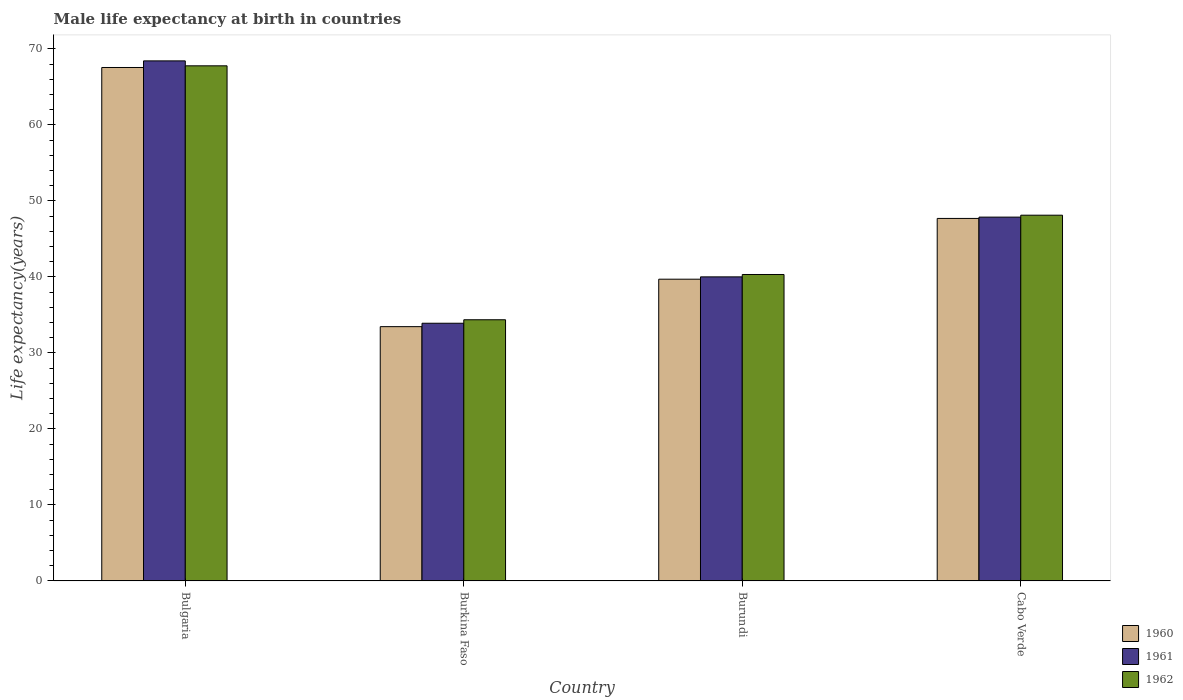How many different coloured bars are there?
Offer a terse response. 3. Are the number of bars on each tick of the X-axis equal?
Provide a succinct answer. Yes. How many bars are there on the 2nd tick from the left?
Provide a succinct answer. 3. What is the label of the 2nd group of bars from the left?
Offer a very short reply. Burkina Faso. In how many cases, is the number of bars for a given country not equal to the number of legend labels?
Your answer should be compact. 0. What is the male life expectancy at birth in 1960 in Bulgaria?
Your answer should be very brief. 67.55. Across all countries, what is the maximum male life expectancy at birth in 1960?
Keep it short and to the point. 67.55. Across all countries, what is the minimum male life expectancy at birth in 1961?
Your answer should be very brief. 33.9. In which country was the male life expectancy at birth in 1962 minimum?
Keep it short and to the point. Burkina Faso. What is the total male life expectancy at birth in 1960 in the graph?
Provide a succinct answer. 188.4. What is the difference between the male life expectancy at birth in 1961 in Bulgaria and that in Cabo Verde?
Give a very brief answer. 20.55. What is the difference between the male life expectancy at birth in 1960 in Burkina Faso and the male life expectancy at birth in 1962 in Cabo Verde?
Offer a very short reply. -14.66. What is the average male life expectancy at birth in 1962 per country?
Provide a succinct answer. 47.64. What is the difference between the male life expectancy at birth of/in 1960 and male life expectancy at birth of/in 1962 in Cabo Verde?
Give a very brief answer. -0.42. In how many countries, is the male life expectancy at birth in 1962 greater than 54 years?
Your answer should be very brief. 1. What is the ratio of the male life expectancy at birth in 1961 in Bulgaria to that in Burundi?
Offer a very short reply. 1.71. Is the male life expectancy at birth in 1961 in Bulgaria less than that in Cabo Verde?
Ensure brevity in your answer.  No. What is the difference between the highest and the second highest male life expectancy at birth in 1962?
Provide a short and direct response. 7.8. What is the difference between the highest and the lowest male life expectancy at birth in 1960?
Your response must be concise. 34.1. Is the sum of the male life expectancy at birth in 1962 in Burundi and Cabo Verde greater than the maximum male life expectancy at birth in 1961 across all countries?
Ensure brevity in your answer.  Yes. Is it the case that in every country, the sum of the male life expectancy at birth in 1960 and male life expectancy at birth in 1962 is greater than the male life expectancy at birth in 1961?
Ensure brevity in your answer.  Yes. How many bars are there?
Your response must be concise. 12. How many countries are there in the graph?
Provide a short and direct response. 4. What is the difference between two consecutive major ticks on the Y-axis?
Your answer should be very brief. 10. Are the values on the major ticks of Y-axis written in scientific E-notation?
Your answer should be compact. No. How many legend labels are there?
Offer a very short reply. 3. How are the legend labels stacked?
Ensure brevity in your answer.  Vertical. What is the title of the graph?
Offer a very short reply. Male life expectancy at birth in countries. Does "1992" appear as one of the legend labels in the graph?
Provide a short and direct response. No. What is the label or title of the X-axis?
Offer a terse response. Country. What is the label or title of the Y-axis?
Provide a succinct answer. Life expectancy(years). What is the Life expectancy(years) in 1960 in Bulgaria?
Keep it short and to the point. 67.55. What is the Life expectancy(years) in 1961 in Bulgaria?
Offer a very short reply. 68.42. What is the Life expectancy(years) of 1962 in Bulgaria?
Your answer should be very brief. 67.77. What is the Life expectancy(years) of 1960 in Burkina Faso?
Ensure brevity in your answer.  33.45. What is the Life expectancy(years) of 1961 in Burkina Faso?
Provide a short and direct response. 33.9. What is the Life expectancy(years) in 1962 in Burkina Faso?
Your answer should be compact. 34.36. What is the Life expectancy(years) in 1960 in Burundi?
Ensure brevity in your answer.  39.7. What is the Life expectancy(years) in 1961 in Burundi?
Keep it short and to the point. 40. What is the Life expectancy(years) of 1962 in Burundi?
Ensure brevity in your answer.  40.32. What is the Life expectancy(years) in 1960 in Cabo Verde?
Provide a succinct answer. 47.69. What is the Life expectancy(years) of 1961 in Cabo Verde?
Offer a very short reply. 47.87. What is the Life expectancy(years) in 1962 in Cabo Verde?
Keep it short and to the point. 48.12. Across all countries, what is the maximum Life expectancy(years) in 1960?
Your response must be concise. 67.55. Across all countries, what is the maximum Life expectancy(years) of 1961?
Keep it short and to the point. 68.42. Across all countries, what is the maximum Life expectancy(years) in 1962?
Give a very brief answer. 67.77. Across all countries, what is the minimum Life expectancy(years) in 1960?
Ensure brevity in your answer.  33.45. Across all countries, what is the minimum Life expectancy(years) in 1961?
Offer a terse response. 33.9. Across all countries, what is the minimum Life expectancy(years) in 1962?
Your answer should be very brief. 34.36. What is the total Life expectancy(years) in 1960 in the graph?
Offer a terse response. 188.4. What is the total Life expectancy(years) of 1961 in the graph?
Your response must be concise. 190.19. What is the total Life expectancy(years) in 1962 in the graph?
Provide a short and direct response. 190.56. What is the difference between the Life expectancy(years) of 1960 in Bulgaria and that in Burkina Faso?
Offer a very short reply. 34.1. What is the difference between the Life expectancy(years) of 1961 in Bulgaria and that in Burkina Faso?
Provide a short and direct response. 34.52. What is the difference between the Life expectancy(years) in 1962 in Bulgaria and that in Burkina Faso?
Provide a succinct answer. 33.41. What is the difference between the Life expectancy(years) of 1960 in Bulgaria and that in Burundi?
Ensure brevity in your answer.  27.85. What is the difference between the Life expectancy(years) in 1961 in Bulgaria and that in Burundi?
Ensure brevity in your answer.  28.42. What is the difference between the Life expectancy(years) of 1962 in Bulgaria and that in Burundi?
Your answer should be compact. 27.45. What is the difference between the Life expectancy(years) of 1960 in Bulgaria and that in Cabo Verde?
Your response must be concise. 19.86. What is the difference between the Life expectancy(years) in 1961 in Bulgaria and that in Cabo Verde?
Your response must be concise. 20.55. What is the difference between the Life expectancy(years) in 1962 in Bulgaria and that in Cabo Verde?
Provide a short and direct response. 19.65. What is the difference between the Life expectancy(years) of 1960 in Burkina Faso and that in Burundi?
Provide a short and direct response. -6.24. What is the difference between the Life expectancy(years) in 1961 in Burkina Faso and that in Burundi?
Provide a succinct answer. -6.1. What is the difference between the Life expectancy(years) of 1962 in Burkina Faso and that in Burundi?
Your response must be concise. -5.96. What is the difference between the Life expectancy(years) of 1960 in Burkina Faso and that in Cabo Verde?
Provide a succinct answer. -14.24. What is the difference between the Life expectancy(years) of 1961 in Burkina Faso and that in Cabo Verde?
Ensure brevity in your answer.  -13.96. What is the difference between the Life expectancy(years) in 1962 in Burkina Faso and that in Cabo Verde?
Your response must be concise. -13.76. What is the difference between the Life expectancy(years) of 1960 in Burundi and that in Cabo Verde?
Offer a very short reply. -8. What is the difference between the Life expectancy(years) of 1961 in Burundi and that in Cabo Verde?
Your answer should be compact. -7.86. What is the difference between the Life expectancy(years) of 1962 in Burundi and that in Cabo Verde?
Offer a terse response. -7.8. What is the difference between the Life expectancy(years) of 1960 in Bulgaria and the Life expectancy(years) of 1961 in Burkina Faso?
Provide a succinct answer. 33.65. What is the difference between the Life expectancy(years) of 1960 in Bulgaria and the Life expectancy(years) of 1962 in Burkina Faso?
Your answer should be compact. 33.19. What is the difference between the Life expectancy(years) in 1961 in Bulgaria and the Life expectancy(years) in 1962 in Burkina Faso?
Offer a terse response. 34.06. What is the difference between the Life expectancy(years) in 1960 in Bulgaria and the Life expectancy(years) in 1961 in Burundi?
Offer a terse response. 27.55. What is the difference between the Life expectancy(years) in 1960 in Bulgaria and the Life expectancy(years) in 1962 in Burundi?
Your answer should be very brief. 27.23. What is the difference between the Life expectancy(years) in 1961 in Bulgaria and the Life expectancy(years) in 1962 in Burundi?
Offer a very short reply. 28.1. What is the difference between the Life expectancy(years) of 1960 in Bulgaria and the Life expectancy(years) of 1961 in Cabo Verde?
Provide a succinct answer. 19.68. What is the difference between the Life expectancy(years) of 1960 in Bulgaria and the Life expectancy(years) of 1962 in Cabo Verde?
Offer a terse response. 19.43. What is the difference between the Life expectancy(years) in 1961 in Bulgaria and the Life expectancy(years) in 1962 in Cabo Verde?
Offer a very short reply. 20.3. What is the difference between the Life expectancy(years) of 1960 in Burkina Faso and the Life expectancy(years) of 1961 in Burundi?
Your answer should be very brief. -6.55. What is the difference between the Life expectancy(years) of 1960 in Burkina Faso and the Life expectancy(years) of 1962 in Burundi?
Keep it short and to the point. -6.86. What is the difference between the Life expectancy(years) in 1961 in Burkina Faso and the Life expectancy(years) in 1962 in Burundi?
Provide a succinct answer. -6.41. What is the difference between the Life expectancy(years) in 1960 in Burkina Faso and the Life expectancy(years) in 1961 in Cabo Verde?
Offer a terse response. -14.41. What is the difference between the Life expectancy(years) in 1960 in Burkina Faso and the Life expectancy(years) in 1962 in Cabo Verde?
Make the answer very short. -14.66. What is the difference between the Life expectancy(years) in 1961 in Burkina Faso and the Life expectancy(years) in 1962 in Cabo Verde?
Your response must be concise. -14.21. What is the difference between the Life expectancy(years) of 1960 in Burundi and the Life expectancy(years) of 1961 in Cabo Verde?
Offer a very short reply. -8.17. What is the difference between the Life expectancy(years) of 1960 in Burundi and the Life expectancy(years) of 1962 in Cabo Verde?
Provide a short and direct response. -8.42. What is the difference between the Life expectancy(years) of 1961 in Burundi and the Life expectancy(years) of 1962 in Cabo Verde?
Your answer should be very brief. -8.11. What is the average Life expectancy(years) in 1960 per country?
Your answer should be compact. 47.1. What is the average Life expectancy(years) in 1961 per country?
Make the answer very short. 47.55. What is the average Life expectancy(years) in 1962 per country?
Your response must be concise. 47.64. What is the difference between the Life expectancy(years) of 1960 and Life expectancy(years) of 1961 in Bulgaria?
Your answer should be compact. -0.87. What is the difference between the Life expectancy(years) in 1960 and Life expectancy(years) in 1962 in Bulgaria?
Your response must be concise. -0.22. What is the difference between the Life expectancy(years) in 1961 and Life expectancy(years) in 1962 in Bulgaria?
Keep it short and to the point. 0.65. What is the difference between the Life expectancy(years) in 1960 and Life expectancy(years) in 1961 in Burkina Faso?
Provide a succinct answer. -0.45. What is the difference between the Life expectancy(years) of 1960 and Life expectancy(years) of 1962 in Burkina Faso?
Your response must be concise. -0.91. What is the difference between the Life expectancy(years) in 1961 and Life expectancy(years) in 1962 in Burkina Faso?
Keep it short and to the point. -0.46. What is the difference between the Life expectancy(years) in 1960 and Life expectancy(years) in 1961 in Burundi?
Provide a succinct answer. -0.31. What is the difference between the Life expectancy(years) of 1960 and Life expectancy(years) of 1962 in Burundi?
Your response must be concise. -0.62. What is the difference between the Life expectancy(years) in 1961 and Life expectancy(years) in 1962 in Burundi?
Offer a terse response. -0.31. What is the difference between the Life expectancy(years) of 1960 and Life expectancy(years) of 1961 in Cabo Verde?
Ensure brevity in your answer.  -0.17. What is the difference between the Life expectancy(years) in 1960 and Life expectancy(years) in 1962 in Cabo Verde?
Offer a very short reply. -0.42. What is the difference between the Life expectancy(years) in 1961 and Life expectancy(years) in 1962 in Cabo Verde?
Your answer should be very brief. -0.25. What is the ratio of the Life expectancy(years) in 1960 in Bulgaria to that in Burkina Faso?
Ensure brevity in your answer.  2.02. What is the ratio of the Life expectancy(years) of 1961 in Bulgaria to that in Burkina Faso?
Offer a very short reply. 2.02. What is the ratio of the Life expectancy(years) of 1962 in Bulgaria to that in Burkina Faso?
Offer a terse response. 1.97. What is the ratio of the Life expectancy(years) of 1960 in Bulgaria to that in Burundi?
Provide a succinct answer. 1.7. What is the ratio of the Life expectancy(years) in 1961 in Bulgaria to that in Burundi?
Your answer should be compact. 1.71. What is the ratio of the Life expectancy(years) of 1962 in Bulgaria to that in Burundi?
Provide a short and direct response. 1.68. What is the ratio of the Life expectancy(years) in 1960 in Bulgaria to that in Cabo Verde?
Give a very brief answer. 1.42. What is the ratio of the Life expectancy(years) of 1961 in Bulgaria to that in Cabo Verde?
Provide a short and direct response. 1.43. What is the ratio of the Life expectancy(years) of 1962 in Bulgaria to that in Cabo Verde?
Provide a succinct answer. 1.41. What is the ratio of the Life expectancy(years) in 1960 in Burkina Faso to that in Burundi?
Give a very brief answer. 0.84. What is the ratio of the Life expectancy(years) of 1961 in Burkina Faso to that in Burundi?
Keep it short and to the point. 0.85. What is the ratio of the Life expectancy(years) in 1962 in Burkina Faso to that in Burundi?
Your answer should be compact. 0.85. What is the ratio of the Life expectancy(years) in 1960 in Burkina Faso to that in Cabo Verde?
Offer a very short reply. 0.7. What is the ratio of the Life expectancy(years) in 1961 in Burkina Faso to that in Cabo Verde?
Offer a terse response. 0.71. What is the ratio of the Life expectancy(years) in 1962 in Burkina Faso to that in Cabo Verde?
Offer a terse response. 0.71. What is the ratio of the Life expectancy(years) of 1960 in Burundi to that in Cabo Verde?
Provide a short and direct response. 0.83. What is the ratio of the Life expectancy(years) in 1961 in Burundi to that in Cabo Verde?
Provide a succinct answer. 0.84. What is the ratio of the Life expectancy(years) of 1962 in Burundi to that in Cabo Verde?
Keep it short and to the point. 0.84. What is the difference between the highest and the second highest Life expectancy(years) in 1960?
Make the answer very short. 19.86. What is the difference between the highest and the second highest Life expectancy(years) of 1961?
Keep it short and to the point. 20.55. What is the difference between the highest and the second highest Life expectancy(years) of 1962?
Give a very brief answer. 19.65. What is the difference between the highest and the lowest Life expectancy(years) in 1960?
Your answer should be very brief. 34.1. What is the difference between the highest and the lowest Life expectancy(years) of 1961?
Keep it short and to the point. 34.52. What is the difference between the highest and the lowest Life expectancy(years) in 1962?
Provide a succinct answer. 33.41. 